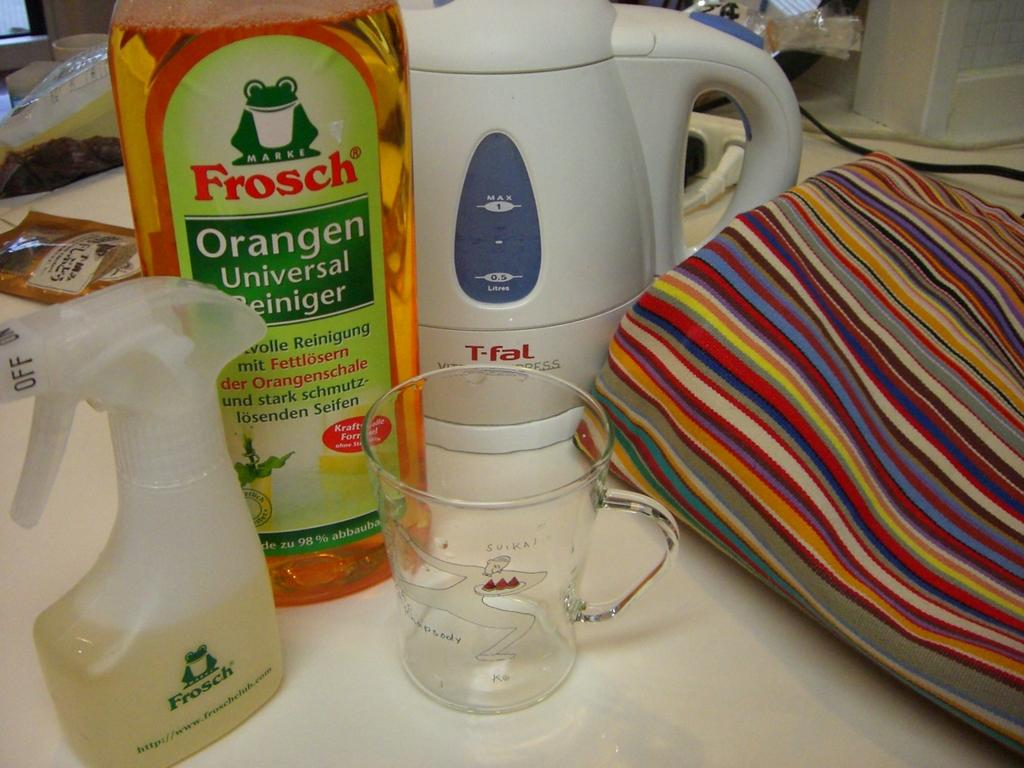Provide a one-sentence caption for the provided image. Frosch Orangen Universal Reiniger is ready to be diluted in the measuring cup and placed into the spray bottle. 